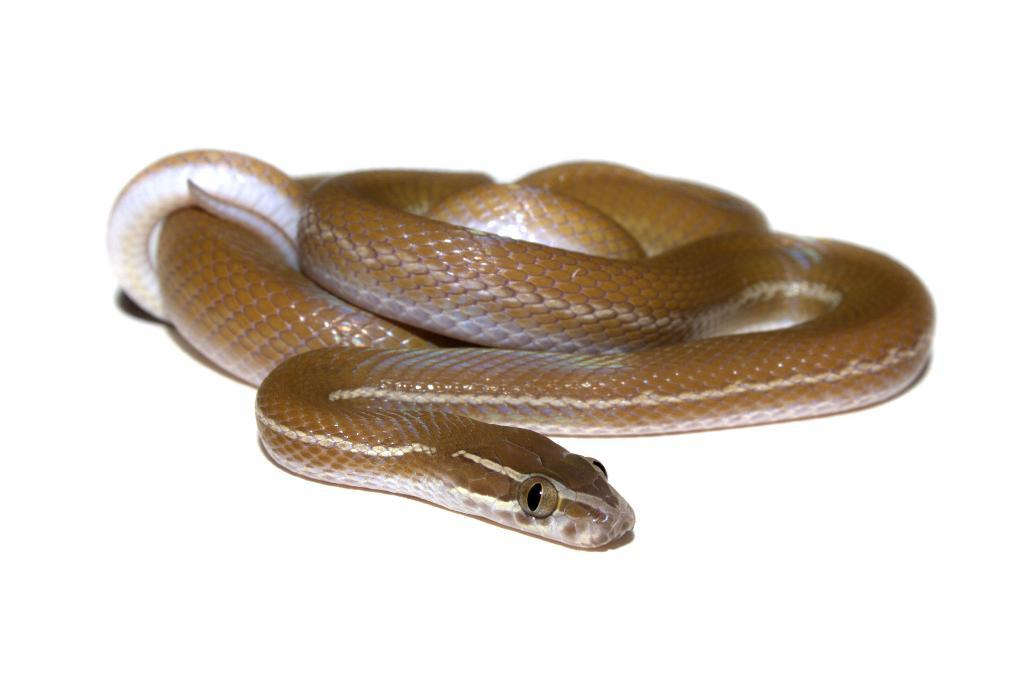What type of animal is present in the image? There is a snake in the image. Where is the snake located? The snake is on the surface. What type of waste is visible in the image? There is no waste visible in the image; it only features a snake on the surface. What color is the paint used on the snake in the image? There is no paint applied to the snake in the image; it is a natural color. 